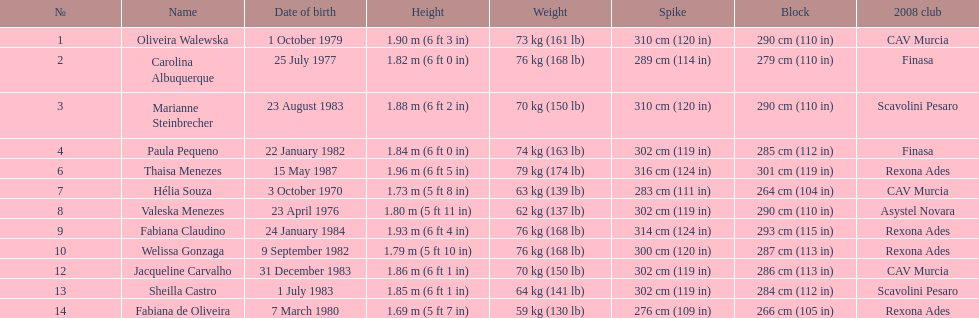Who is the next highest participant after thaisa menezes? Fabiana Claudino. 